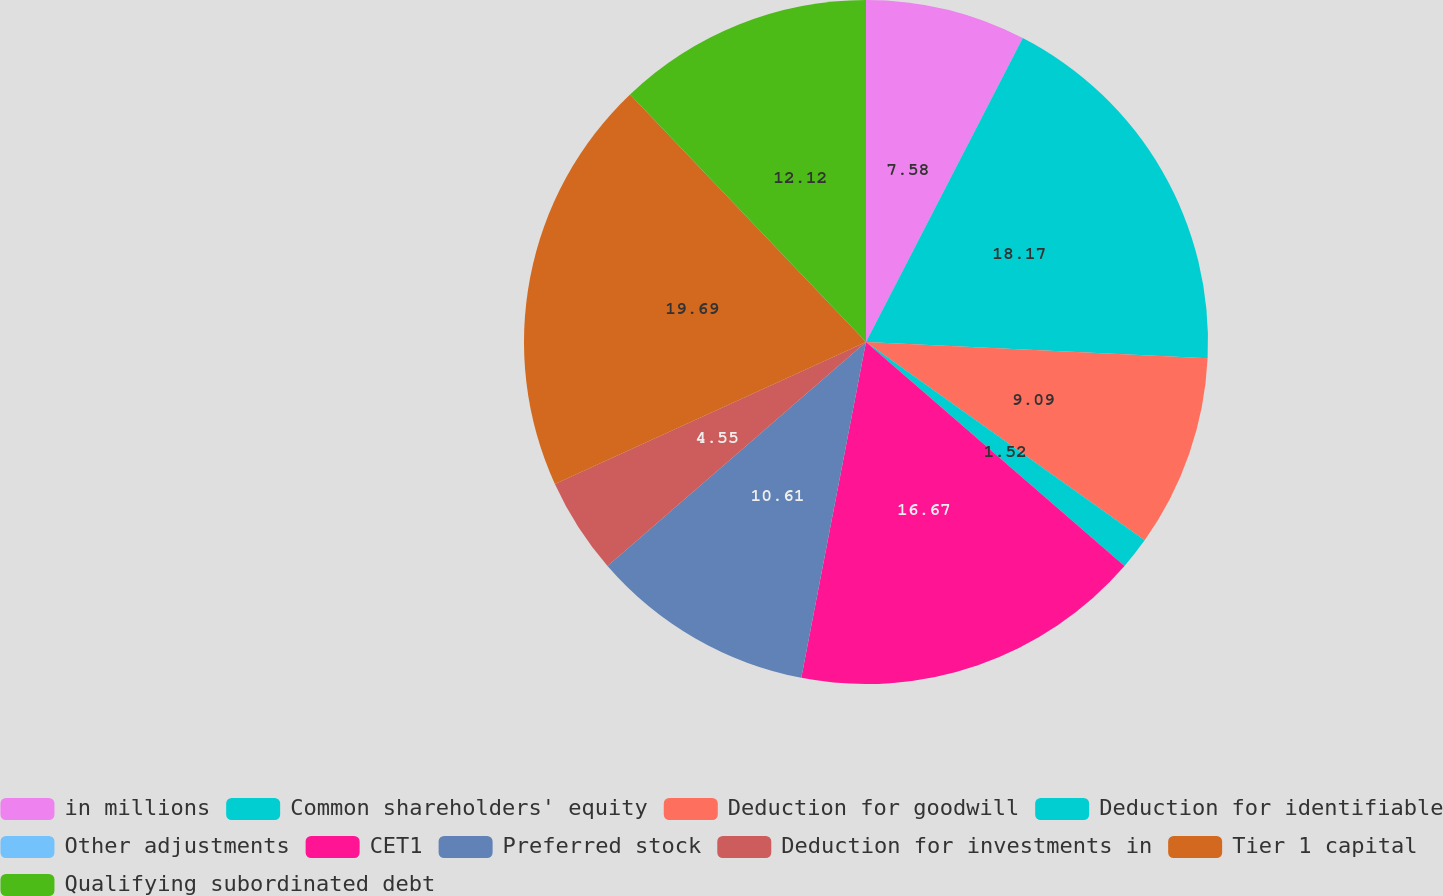Convert chart to OTSL. <chart><loc_0><loc_0><loc_500><loc_500><pie_chart><fcel>in millions<fcel>Common shareholders' equity<fcel>Deduction for goodwill<fcel>Deduction for identifiable<fcel>Other adjustments<fcel>CET1<fcel>Preferred stock<fcel>Deduction for investments in<fcel>Tier 1 capital<fcel>Qualifying subordinated debt<nl><fcel>7.58%<fcel>18.18%<fcel>9.09%<fcel>1.52%<fcel>0.0%<fcel>16.67%<fcel>10.61%<fcel>4.55%<fcel>19.7%<fcel>12.12%<nl></chart> 